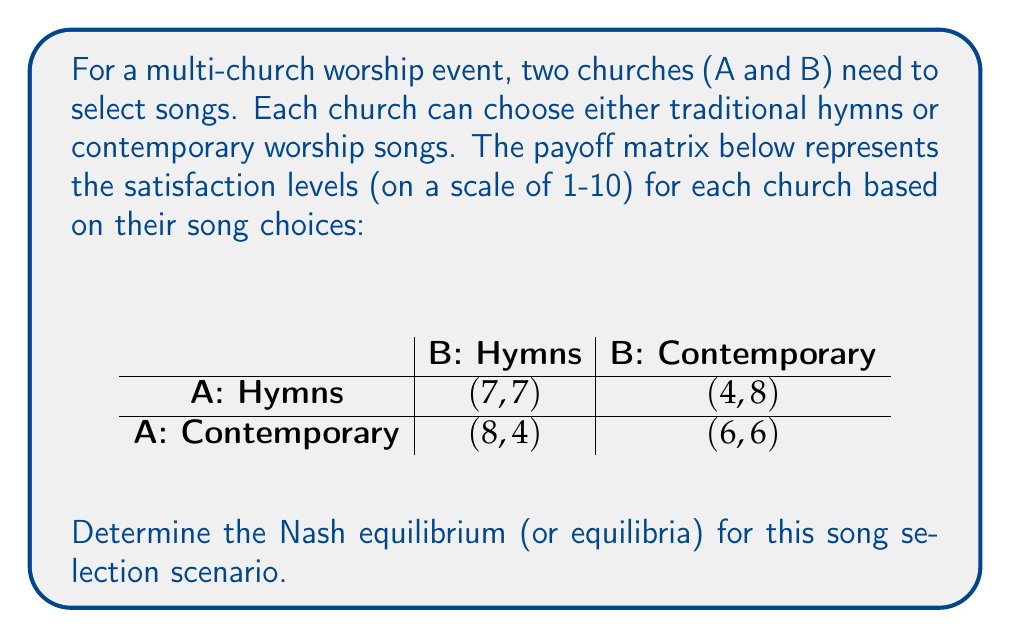What is the answer to this math problem? To find the Nash equilibrium, we need to analyze each church's best response to the other church's strategy:

1. For Church A:
   - If B chooses Hymns: A's best response is Contemporary (8 > 7)
   - If B chooses Contemporary: A's best response is Hymns (4 > 6)

2. For Church B:
   - If A chooses Hymns: B's best response is Contemporary (8 > 7)
   - If A chooses Contemporary: B's best response is Hymns (4 > 6)

3. Nash equilibrium occurs when each player's strategy is the best response to the other player's strategy.

4. Examining the payoff matrix:
   - (Hymns, Hymns) is not Nash equilibrium because B would deviate to Contemporary
   - (Hymns, Contemporary) is Nash equilibrium because neither would unilaterally deviate
   - (Contemporary, Hymns) is Nash equilibrium because neither would unilaterally deviate
   - (Contemporary, Contemporary) is not Nash equilibrium because A would deviate to Hymns

5. Therefore, there are two Nash equilibria in this scenario:
   - (Hymns, Contemporary)
   - (Contemporary, Hymns)

These equilibria represent stable outcomes where neither church has an incentive to change their strategy given the other church's choice.
Answer: The Nash equilibria for this song selection scenario are (Hymns, Contemporary) and (Contemporary, Hymns). 